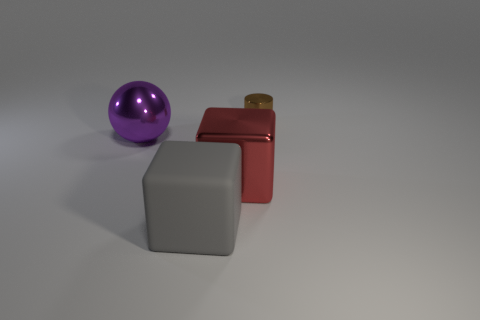Subtract all gray cubes. How many cubes are left? 1 Add 1 tiny blue metal cubes. How many objects exist? 5 Subtract all spheres. How many objects are left? 3 Subtract 1 cubes. How many cubes are left? 1 Subtract all yellow cubes. Subtract all blue cylinders. How many cubes are left? 2 Subtract all yellow blocks. How many red cylinders are left? 0 Add 4 red metal things. How many red metal things exist? 5 Subtract 1 purple spheres. How many objects are left? 3 Subtract all brown metal cylinders. Subtract all brown things. How many objects are left? 2 Add 3 big red blocks. How many big red blocks are left? 4 